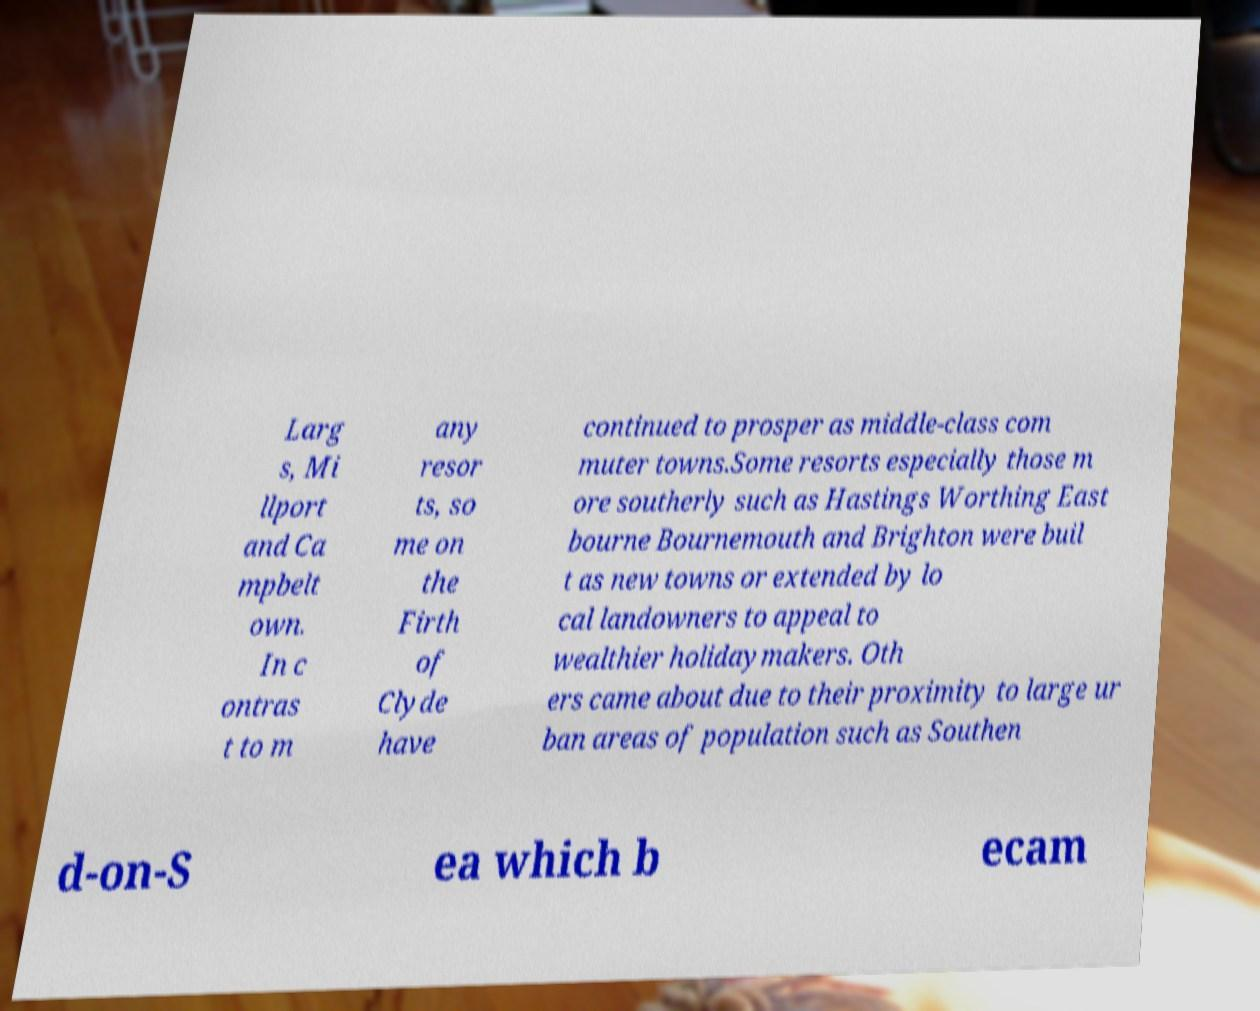Can you read and provide the text displayed in the image?This photo seems to have some interesting text. Can you extract and type it out for me? Larg s, Mi llport and Ca mpbelt own. In c ontras t to m any resor ts, so me on the Firth of Clyde have continued to prosper as middle-class com muter towns.Some resorts especially those m ore southerly such as Hastings Worthing East bourne Bournemouth and Brighton were buil t as new towns or extended by lo cal landowners to appeal to wealthier holidaymakers. Oth ers came about due to their proximity to large ur ban areas of population such as Southen d-on-S ea which b ecam 